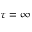<formula> <loc_0><loc_0><loc_500><loc_500>\tau = \infty</formula> 